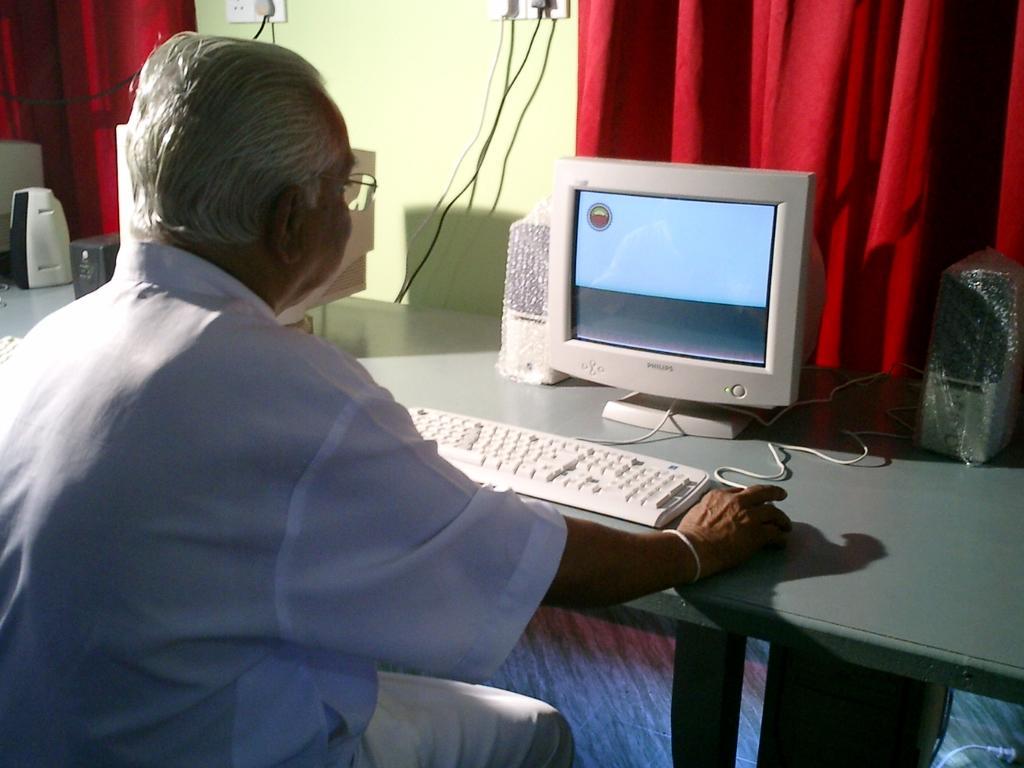Can you describe this image briefly? In the image there is a person sitting in front of a table and on the table there is a computer system and some speakers, behind the system there are red curtains beside the wall. 